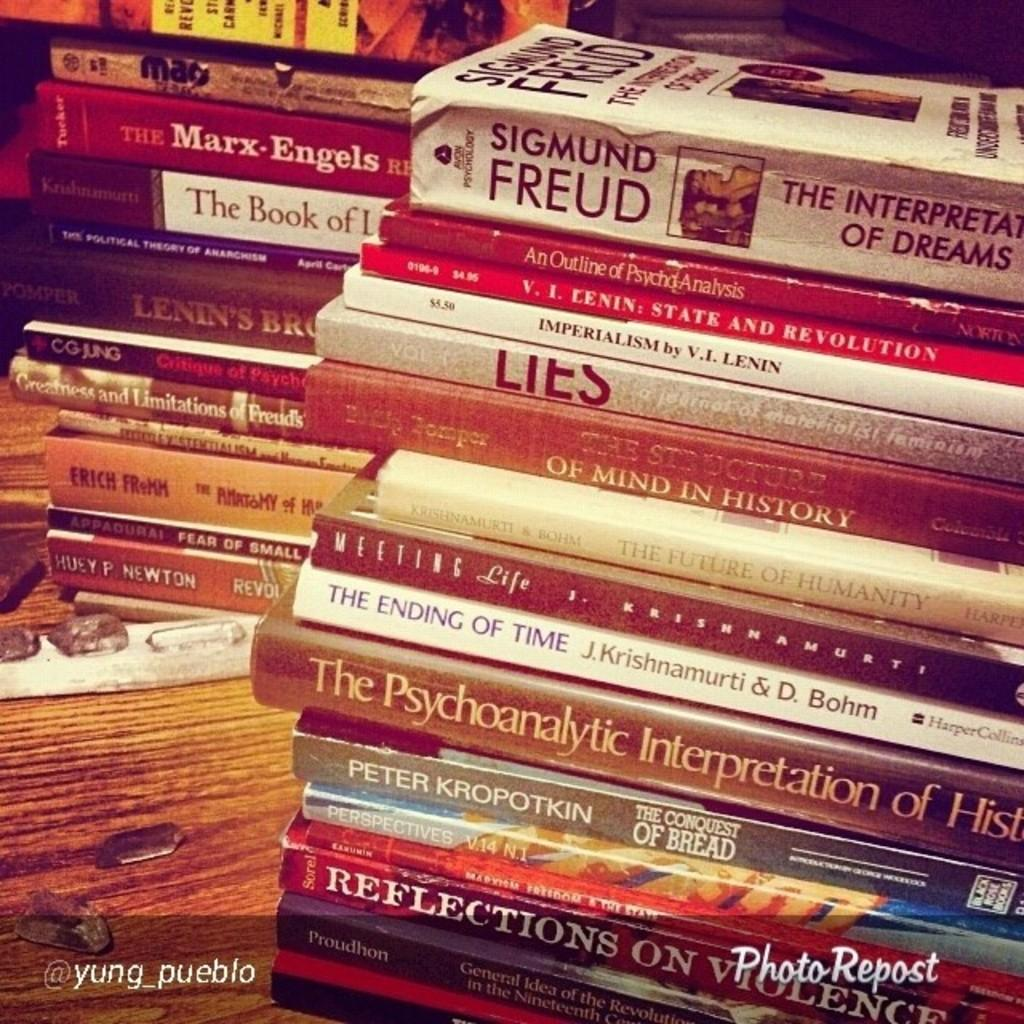<image>
Relay a brief, clear account of the picture shown. A stack of book with the top one by Sigmund Freud. 